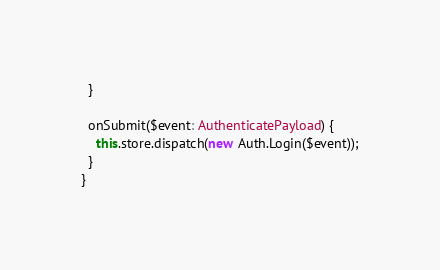<code> <loc_0><loc_0><loc_500><loc_500><_TypeScript_>  }

  onSubmit($event: AuthenticatePayload) {
    this.store.dispatch(new Auth.Login($event));
  }
}
</code> 